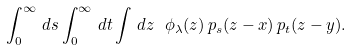<formula> <loc_0><loc_0><loc_500><loc_500>\int _ { 0 } ^ { \infty } \, d s \int _ { 0 } ^ { \infty } \, d t \int \, { d } z \ \phi _ { \lambda } ( z ) \, p _ { s } ( z - x ) \, p _ { t } ( z - y ) .</formula> 